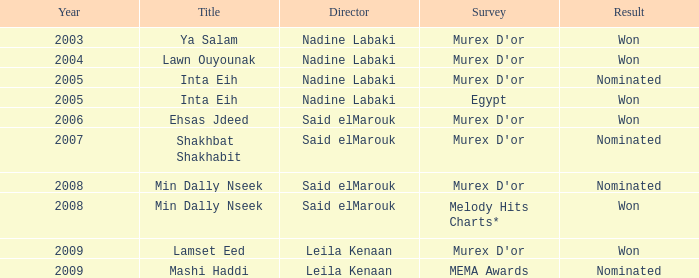What survey has the Ehsas Jdeed title? Murex D'or. 